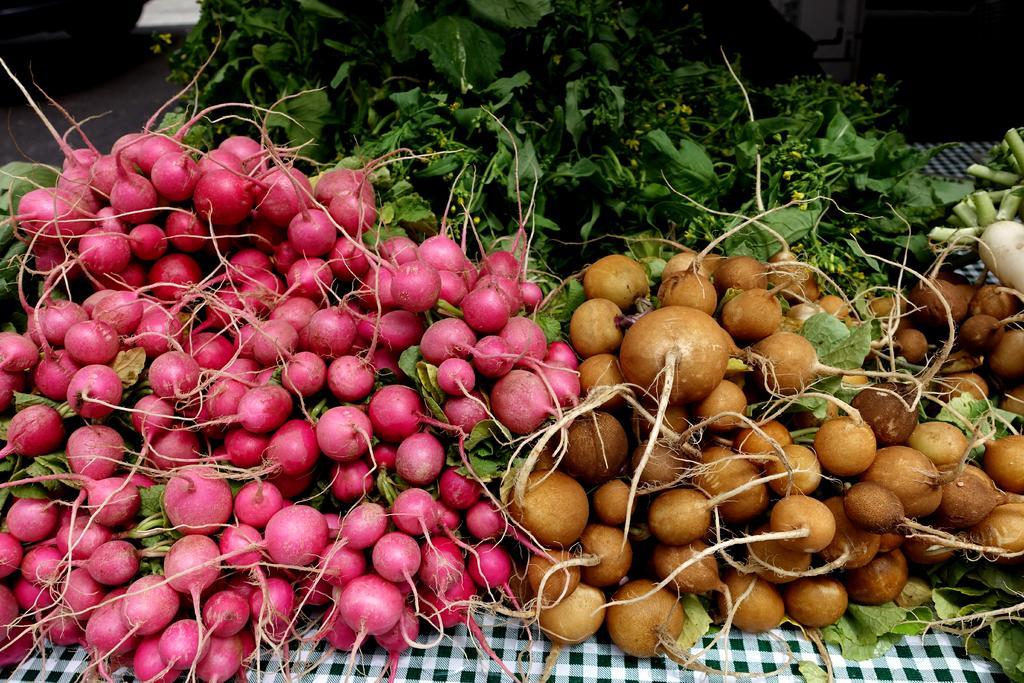Can you describe this image briefly? In this picture we can see different type of vegetables on the table. At the bottom we can see the cloth. In the top left corner there is a wheel on the road. 